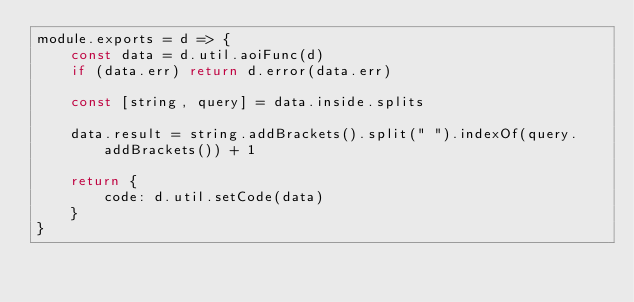<code> <loc_0><loc_0><loc_500><loc_500><_JavaScript_>module.exports = d => {
    const data = d.util.aoiFunc(d)
    if (data.err) return d.error(data.err)

    const [string, query] = data.inside.splits

    data.result = string.addBrackets().split(" ").indexOf(query.addBrackets()) + 1

    return {
        code: d.util.setCode(data)
    }
}
</code> 